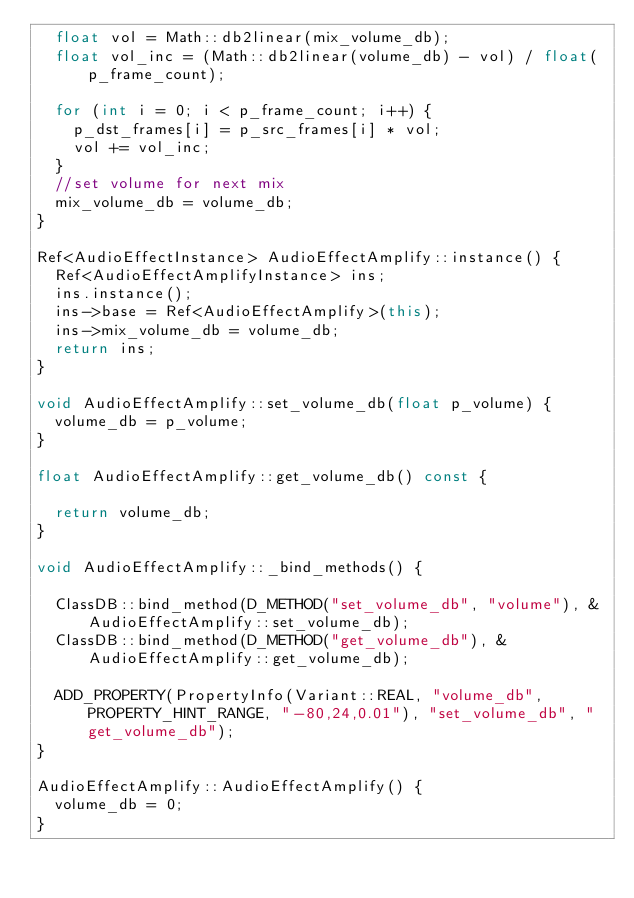Convert code to text. <code><loc_0><loc_0><loc_500><loc_500><_C++_>	float vol = Math::db2linear(mix_volume_db);
	float vol_inc = (Math::db2linear(volume_db) - vol) / float(p_frame_count);

	for (int i = 0; i < p_frame_count; i++) {
		p_dst_frames[i] = p_src_frames[i] * vol;
		vol += vol_inc;
	}
	//set volume for next mix
	mix_volume_db = volume_db;
}

Ref<AudioEffectInstance> AudioEffectAmplify::instance() {
	Ref<AudioEffectAmplifyInstance> ins;
	ins.instance();
	ins->base = Ref<AudioEffectAmplify>(this);
	ins->mix_volume_db = volume_db;
	return ins;
}

void AudioEffectAmplify::set_volume_db(float p_volume) {
	volume_db = p_volume;
}

float AudioEffectAmplify::get_volume_db() const {

	return volume_db;
}

void AudioEffectAmplify::_bind_methods() {

	ClassDB::bind_method(D_METHOD("set_volume_db", "volume"), &AudioEffectAmplify::set_volume_db);
	ClassDB::bind_method(D_METHOD("get_volume_db"), &AudioEffectAmplify::get_volume_db);

	ADD_PROPERTY(PropertyInfo(Variant::REAL, "volume_db", PROPERTY_HINT_RANGE, "-80,24,0.01"), "set_volume_db", "get_volume_db");
}

AudioEffectAmplify::AudioEffectAmplify() {
	volume_db = 0;
}
</code> 